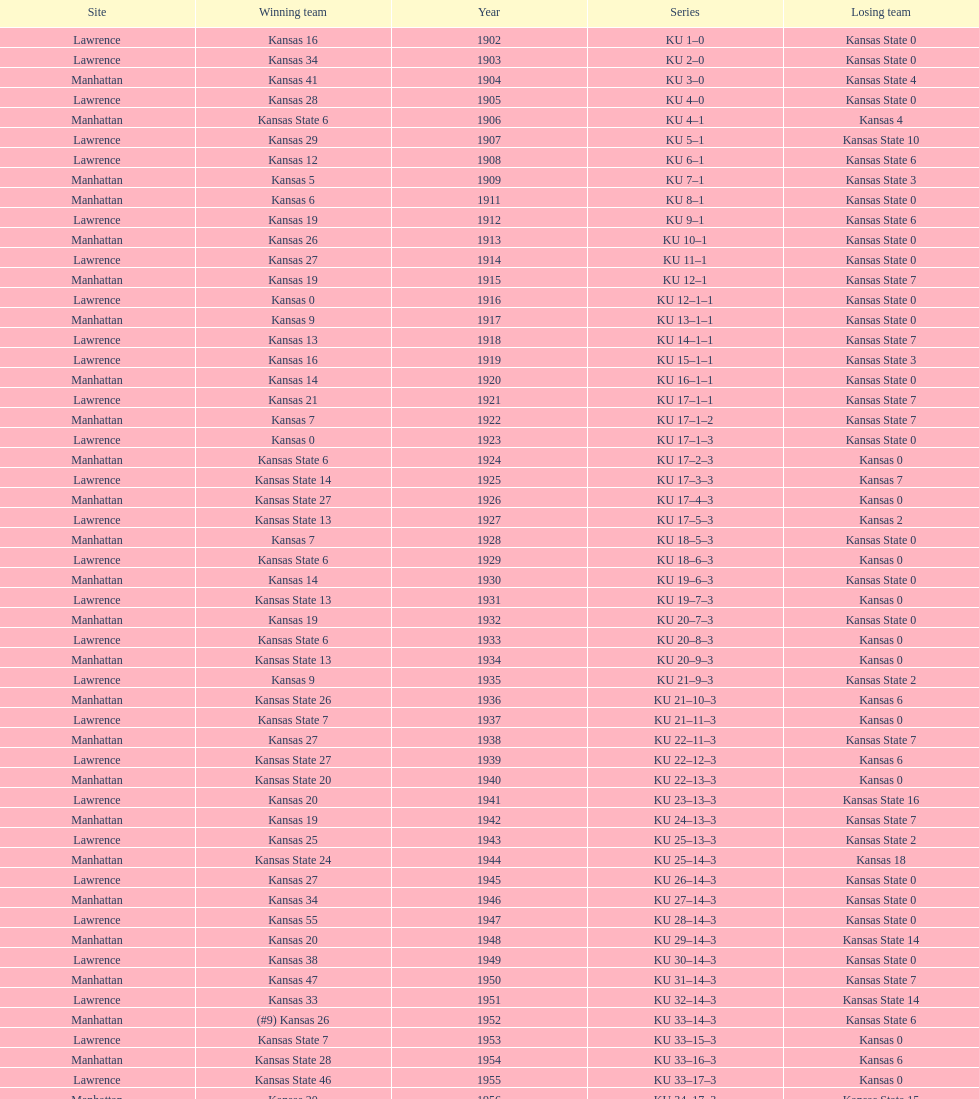How many times did kansas and kansas state play in lawrence from 1902-1968? 34. 